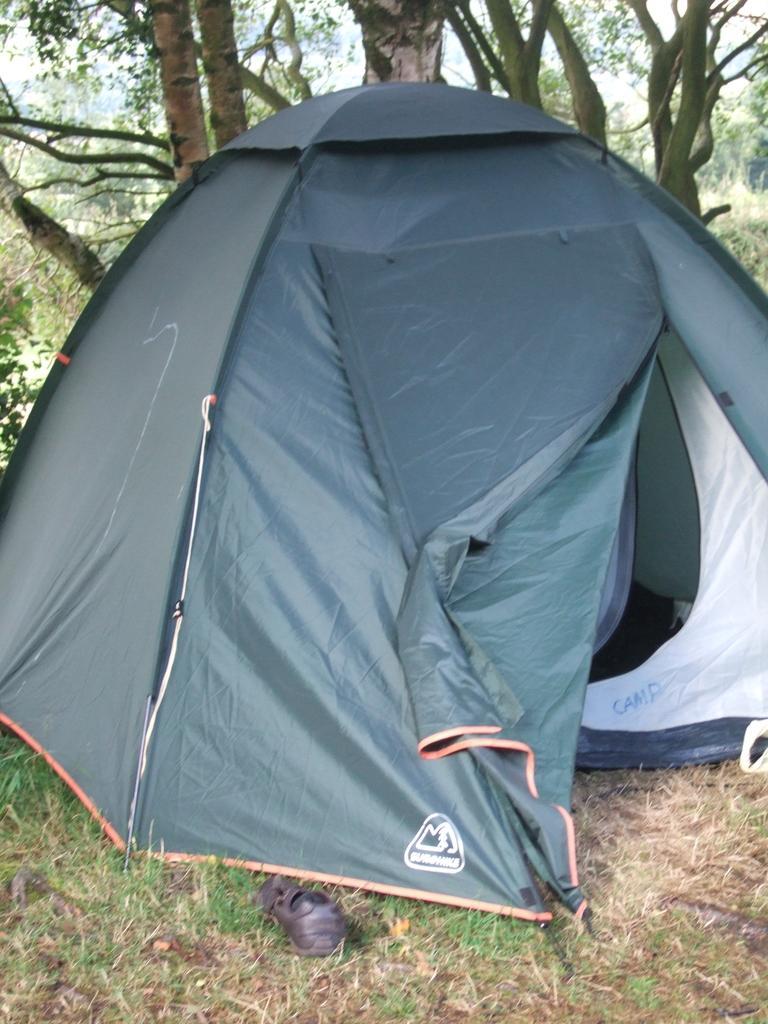Please provide a concise description of this image. In this image I can see a tent. In the background I can see trees and the grass. Here I can see something on the ground. 